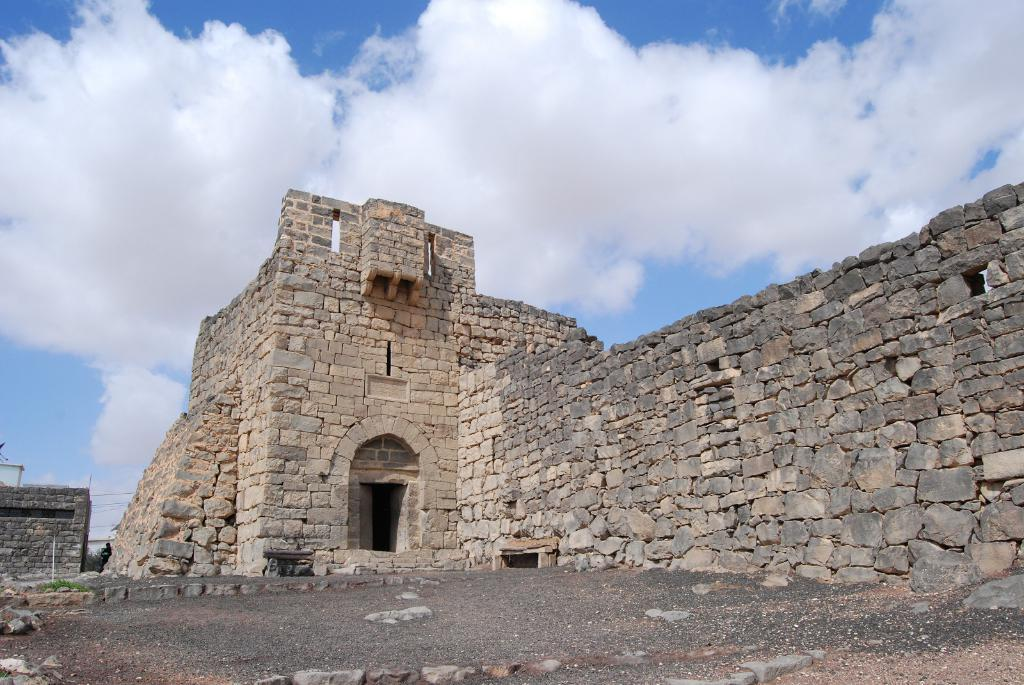What type of structure is in the image? There is a fort in the image. What colors are used to depict the fort? The fort is in grey and ash color. What can be seen in the background of the image? There are clouds and a blue sky in the background of the image. Where is the cobweb located in the image? There is no cobweb present in the image. What type of religious building can be seen in the image? There is no church or any religious building present in the image; it features a fort. 